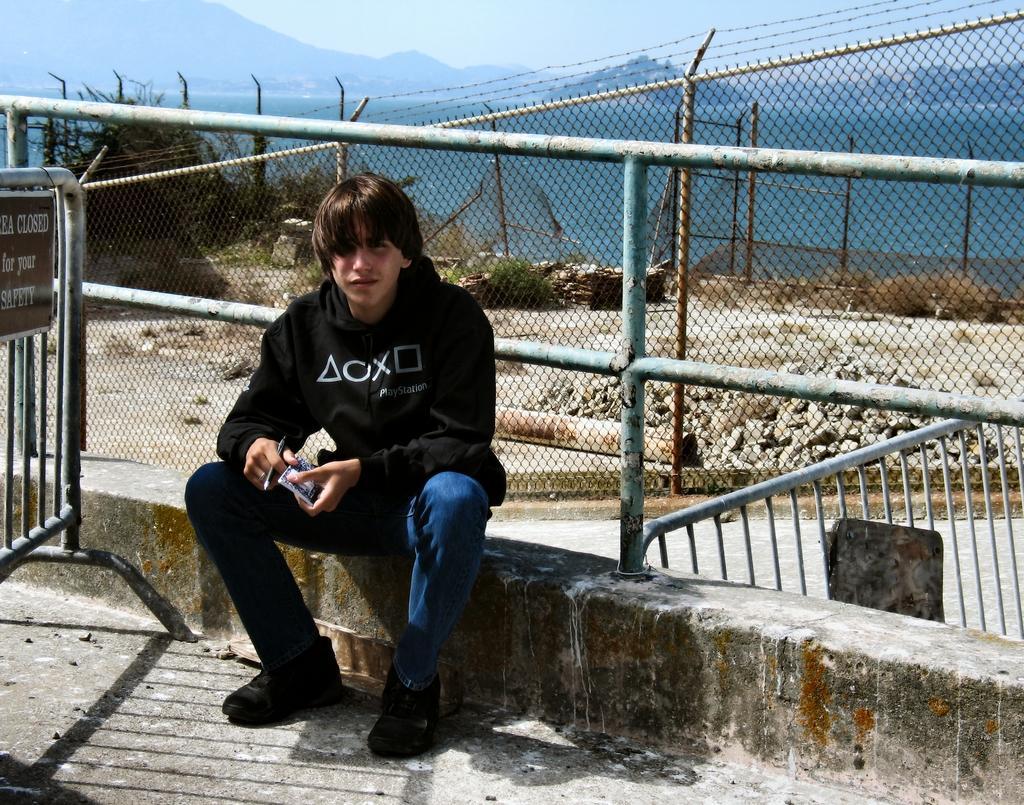How would you summarize this image in a sentence or two? In this image we can see a boy is sitting. He is wearing black color hoodie with jeans and holding book and pen in his hand. Behind him railing, fencing, mountains and plants are there. Left side of the image we can see the fencing with one board. Right side of the image, stone are there on the land and one pole is present on the land. 